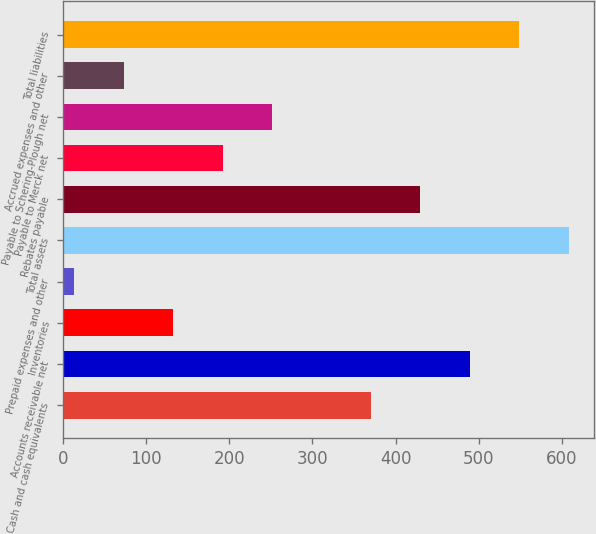<chart> <loc_0><loc_0><loc_500><loc_500><bar_chart><fcel>Cash and cash equivalents<fcel>Accounts receivable net<fcel>Inventories<fcel>Prepaid expenses and other<fcel>Total assets<fcel>Rebates payable<fcel>Payable to Merck net<fcel>Payable to Schering-Plough net<fcel>Accrued expenses and other<fcel>Total liabilities<nl><fcel>370.4<fcel>489.2<fcel>132.8<fcel>14<fcel>608<fcel>429.8<fcel>192.2<fcel>251.6<fcel>73.4<fcel>548.6<nl></chart> 